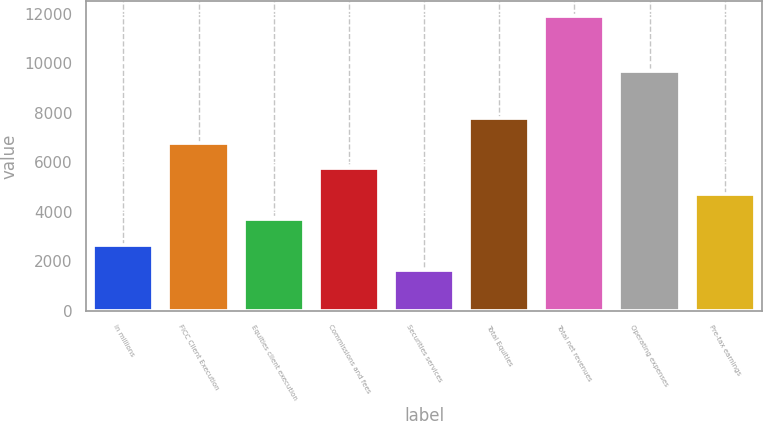Convert chart. <chart><loc_0><loc_0><loc_500><loc_500><bar_chart><fcel>in millions<fcel>FICC Client Execution<fcel>Equities client execution<fcel>Commissions and fees<fcel>Securities services<fcel>Total Equities<fcel>Total net revenues<fcel>Operating expenses<fcel>Pre-tax earnings<nl><fcel>2663.5<fcel>6769.5<fcel>3690<fcel>5743<fcel>1637<fcel>7796<fcel>11902<fcel>9692<fcel>4716.5<nl></chart> 